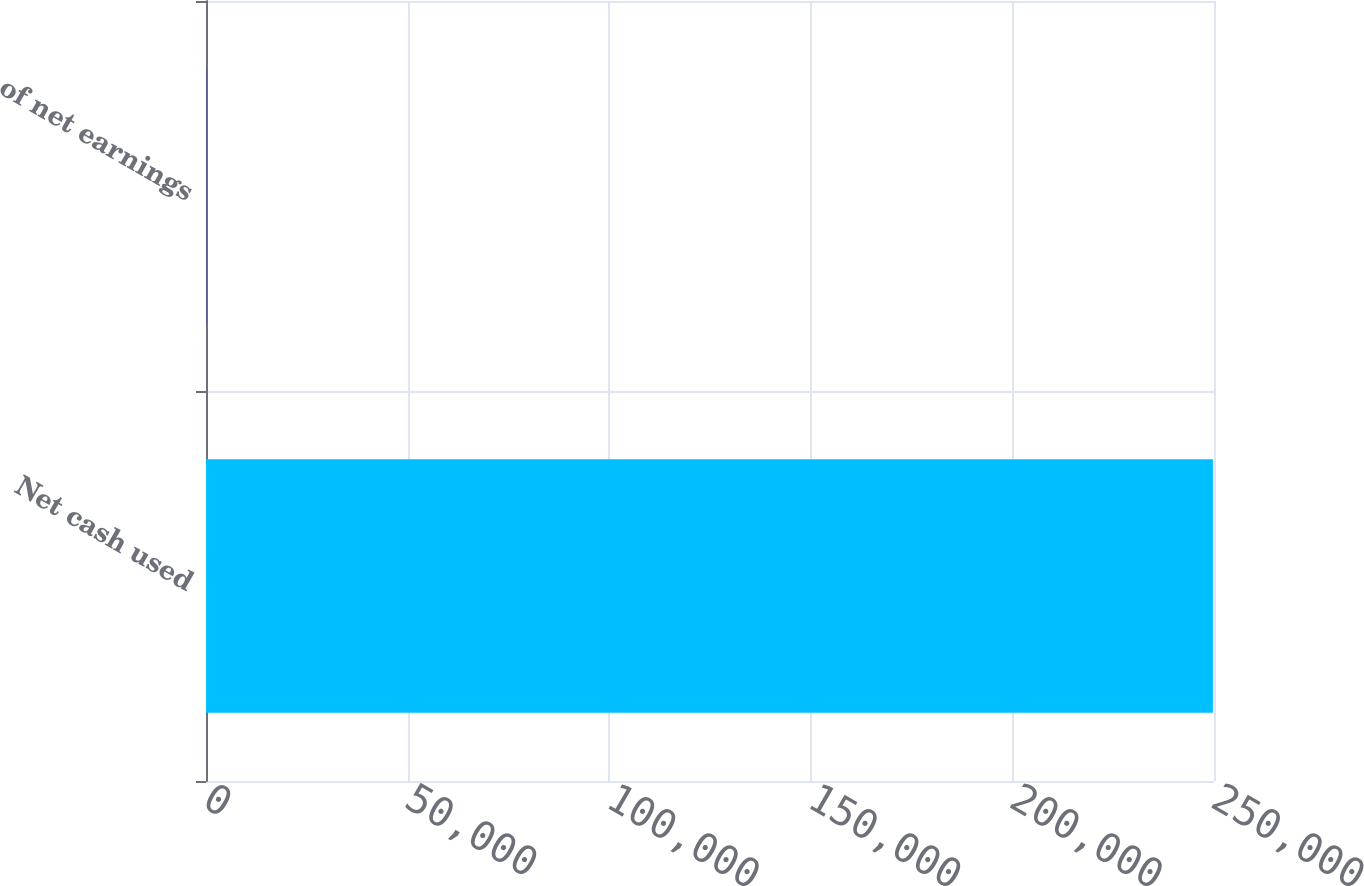<chart> <loc_0><loc_0><loc_500><loc_500><bar_chart><fcel>Net cash used<fcel>of net earnings<nl><fcel>249732<fcel>50.5<nl></chart> 